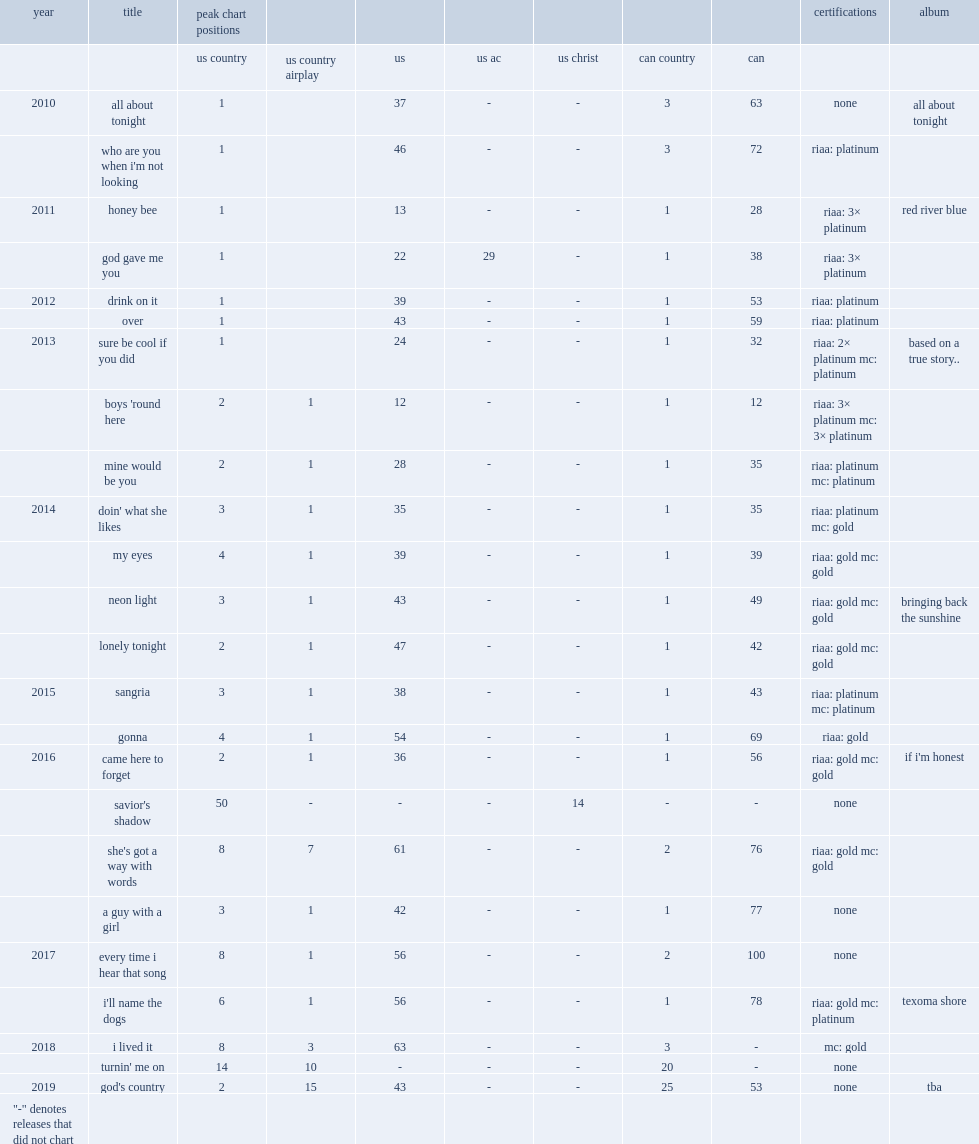When did all about tonight release? 2010.0. 